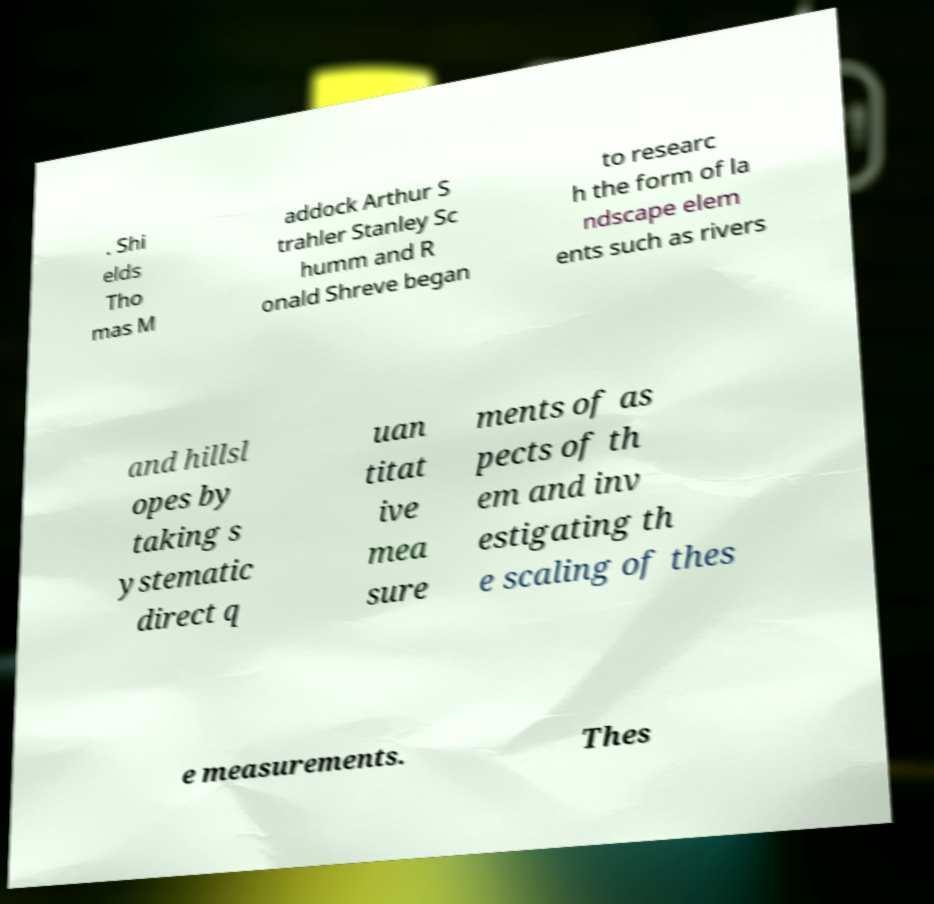Could you extract and type out the text from this image? . Shi elds Tho mas M addock Arthur S trahler Stanley Sc humm and R onald Shreve began to researc h the form of la ndscape elem ents such as rivers and hillsl opes by taking s ystematic direct q uan titat ive mea sure ments of as pects of th em and inv estigating th e scaling of thes e measurements. Thes 